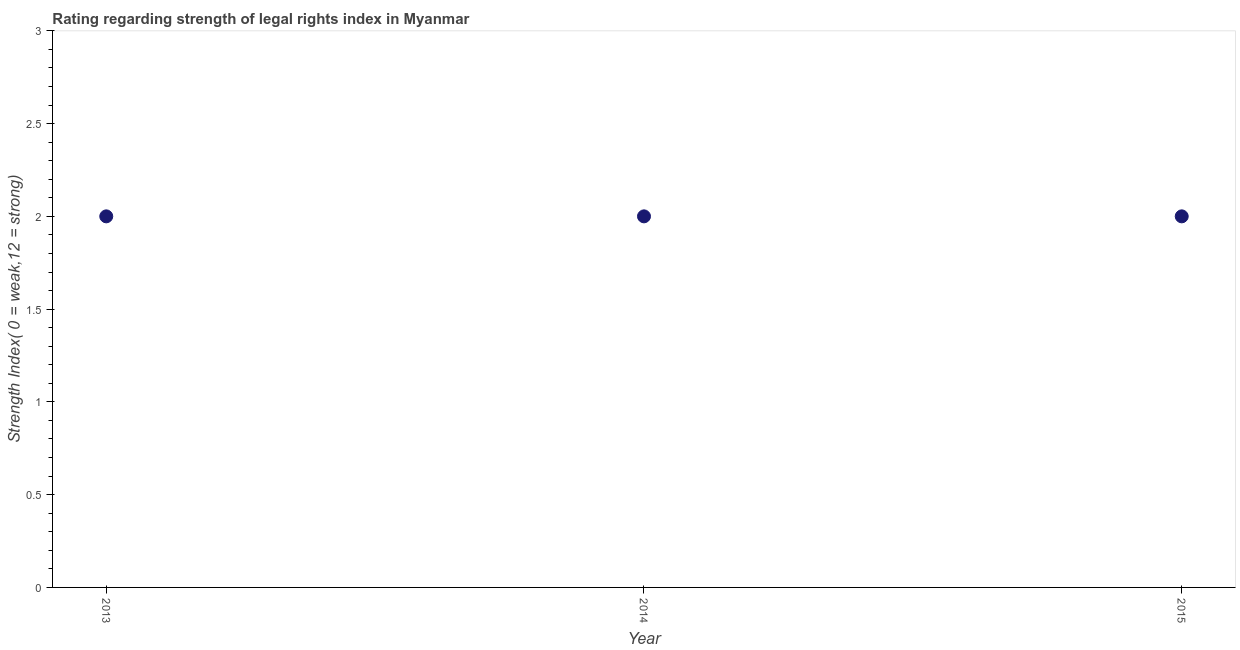What is the strength of legal rights index in 2014?
Keep it short and to the point. 2. Across all years, what is the maximum strength of legal rights index?
Your answer should be very brief. 2. Across all years, what is the minimum strength of legal rights index?
Provide a succinct answer. 2. In which year was the strength of legal rights index minimum?
Make the answer very short. 2013. What is the difference between the strength of legal rights index in 2013 and 2015?
Ensure brevity in your answer.  0. What is the average strength of legal rights index per year?
Ensure brevity in your answer.  2. Is the difference between the strength of legal rights index in 2014 and 2015 greater than the difference between any two years?
Your answer should be very brief. Yes. In how many years, is the strength of legal rights index greater than the average strength of legal rights index taken over all years?
Your answer should be very brief. 0. How many years are there in the graph?
Offer a terse response. 3. What is the difference between two consecutive major ticks on the Y-axis?
Your answer should be compact. 0.5. Are the values on the major ticks of Y-axis written in scientific E-notation?
Ensure brevity in your answer.  No. Does the graph contain any zero values?
Offer a very short reply. No. What is the title of the graph?
Provide a succinct answer. Rating regarding strength of legal rights index in Myanmar. What is the label or title of the X-axis?
Your answer should be very brief. Year. What is the label or title of the Y-axis?
Your answer should be very brief. Strength Index( 0 = weak,12 = strong). What is the Strength Index( 0 = weak,12 = strong) in 2013?
Your answer should be very brief. 2. What is the Strength Index( 0 = weak,12 = strong) in 2014?
Offer a terse response. 2. What is the Strength Index( 0 = weak,12 = strong) in 2015?
Your response must be concise. 2. What is the difference between the Strength Index( 0 = weak,12 = strong) in 2013 and 2014?
Offer a terse response. 0. What is the difference between the Strength Index( 0 = weak,12 = strong) in 2013 and 2015?
Offer a very short reply. 0. What is the ratio of the Strength Index( 0 = weak,12 = strong) in 2013 to that in 2015?
Ensure brevity in your answer.  1. What is the ratio of the Strength Index( 0 = weak,12 = strong) in 2014 to that in 2015?
Offer a terse response. 1. 